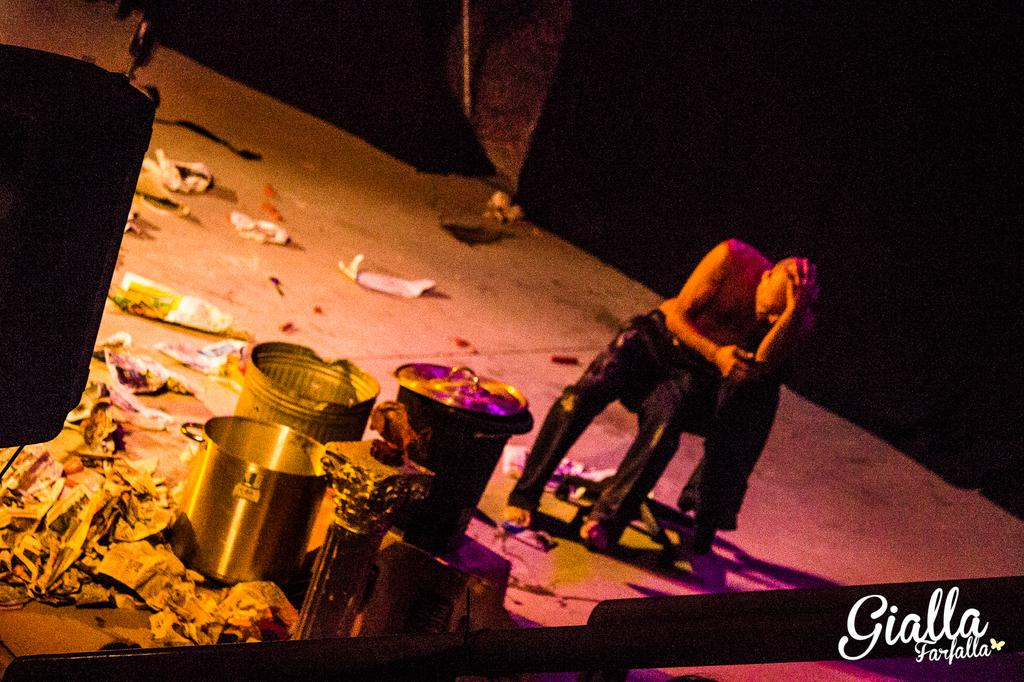What objects are in the foreground of the picture? There are bins, papers, text, an iron frame, and other objects in the foreground of the picture. What type of material is the text written on? A: The text is written on papers in the foreground of the picture. What can be seen in the background of the picture? There is a wall visible in the background of the picture. What is located at the top left of the picture? There is an object at the top left of the picture. How many fans are visible in the picture? There are no fans present in the picture. What type of letters are being sent through the arch in the picture? There is no arch present in the picture, and therefore no letters can be sent through it. 